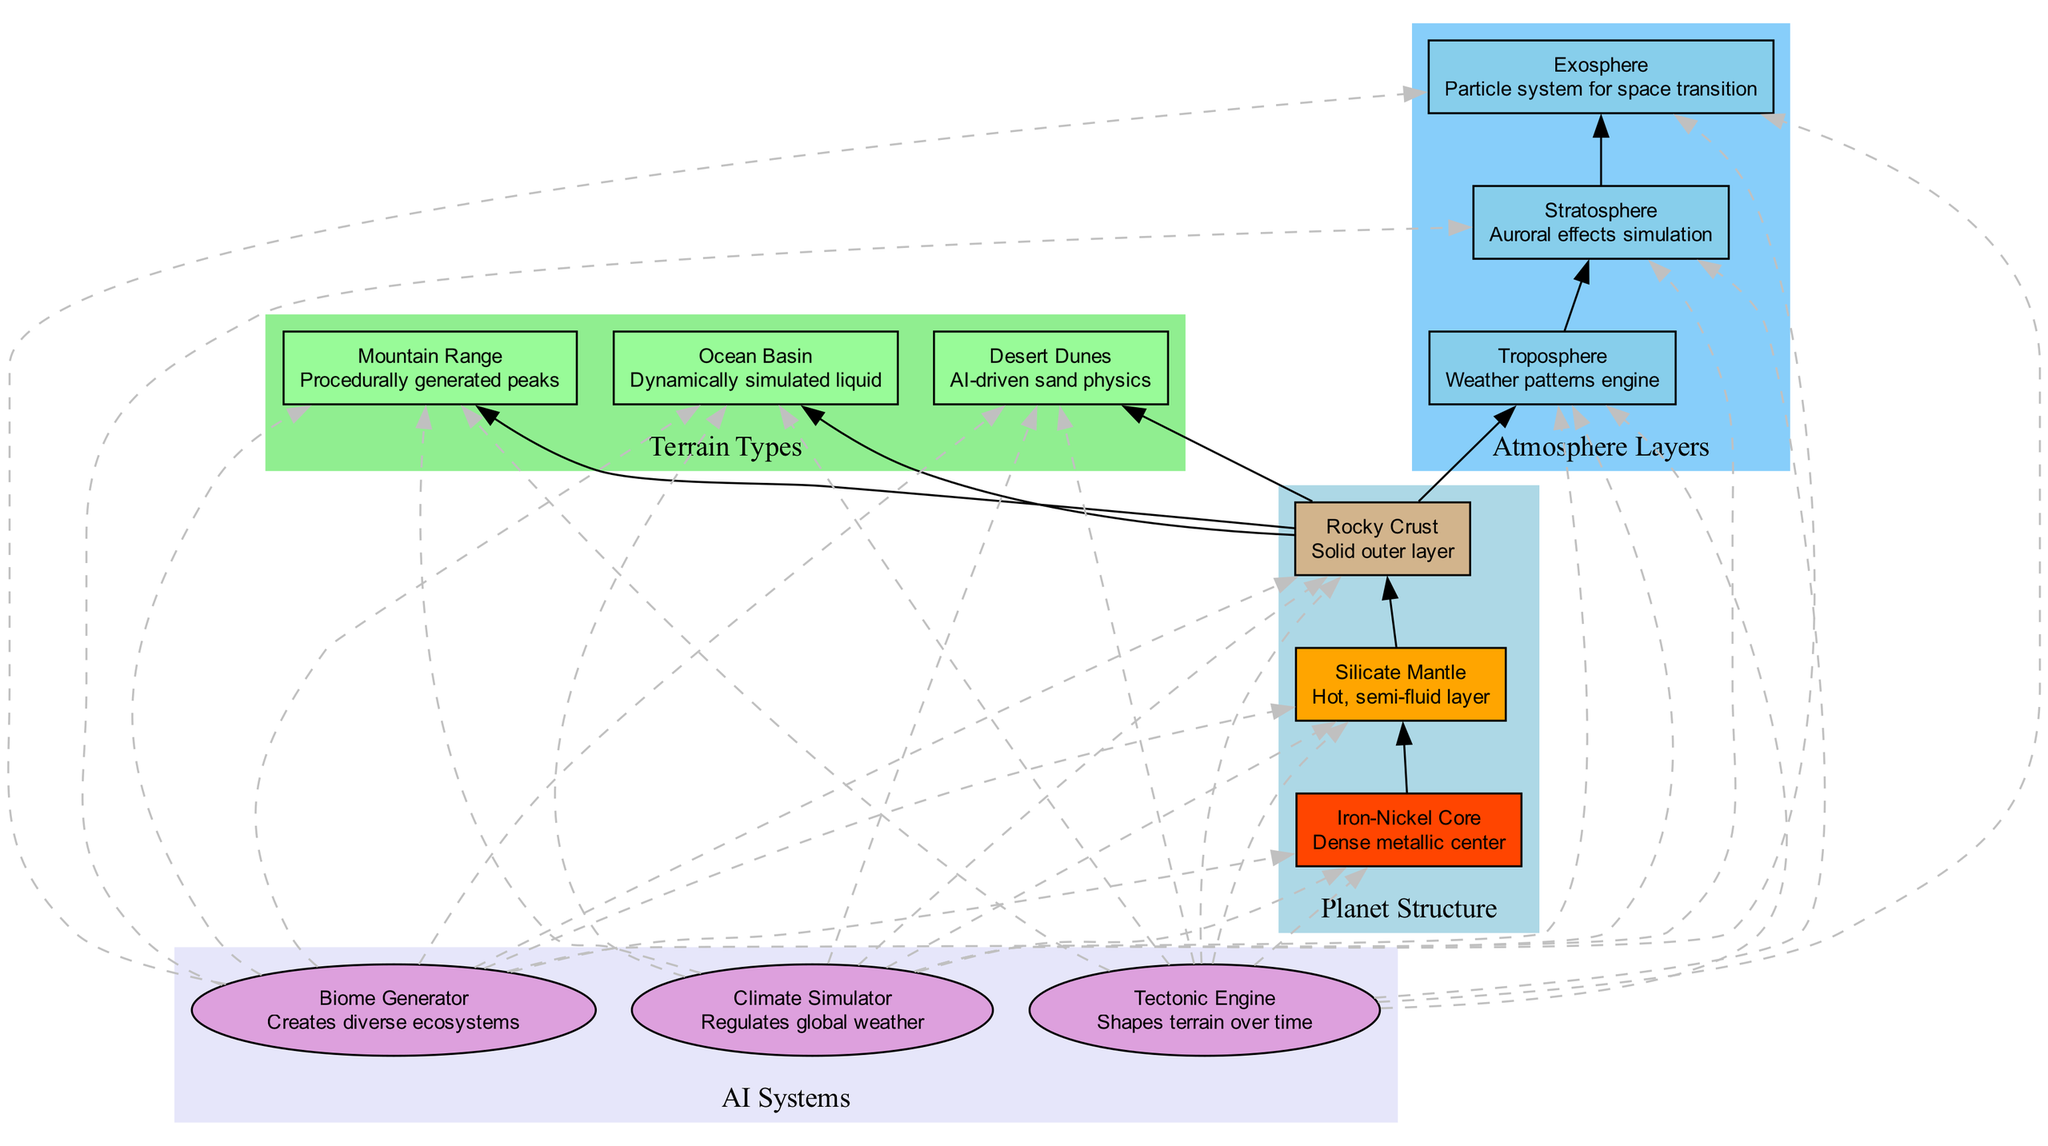What is the name of the core layer? By looking at the topmost section of the planet structure, we can see that the layer labeled as "Core" has "Iron-Nickel Core" indicated.
Answer: Iron-Nickel Core What type of atmosphere layer follows the Stratosphere? In the atmosphere layers section of the diagram, after "Stratosphere", the next layer is directly connected to it and labeled "Exosphere".
Answer: Exosphere How many types of terrain are represented in the diagram? By counting the nodes in the Terrain Types subgraph, there are three distinct terrain types listed.
Answer: 3 Which AI system is responsible for creating diverse ecosystems? In the AI Systems section, the first system listed is "Biome Generator," which is specifically described as creating diverse ecosystems.
Answer: Biome Generator Which terrain type is described as having dynamically simulated liquid? Referring to the Terrain Types section, the "Ocean Basin" is indicated as the type associated with dynamically simulated liquid.
Answer: Ocean Basin In which order do the atmosphere layers appear? The atmosphere layers in the diagram are organized from bottom to top as Troposphere, Stratosphere, and Exosphere. Therefore, they appear in that specific order.
Answer: Troposphere, Stratosphere, Exosphere What color represents the Silicate Mantle in the diagram? The Silicate Mantle is represented in orange in the diagram, as indicated by the color used in its corresponding box.
Answer: Orange How do the AI systems connect to the terrain types? In the AI Systems section, each AI system (e.g., Biome Generator, Climate Simulator, Tectonic Engine) shows dashed edges leading to each terrain type, indicating that they influence or generate these terrains.
Answer: Dashed edges to all terrain types What function does the Tectonic Engine fulfill? The description next to the Tectonic Engine specifies that it is responsible for shaping terrain over time, indicating its role in geographical changes.
Answer: Shapes terrain over time 